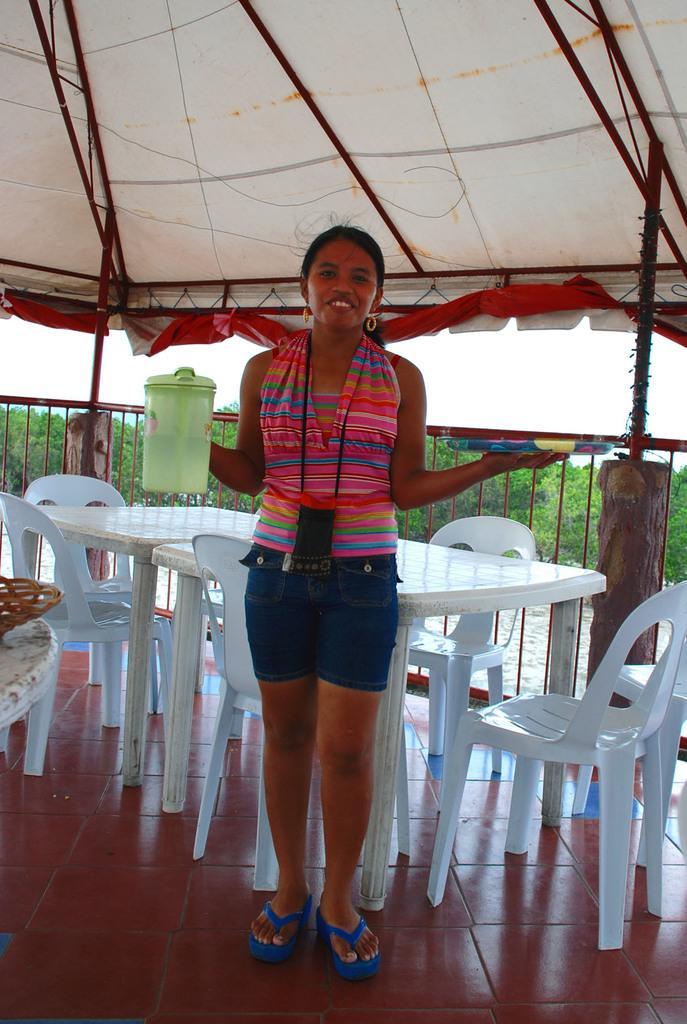How would you summarize this image in a sentence or two? Under the tent there is a girl standing. She is holding a jug in her right hand and a plate in the right hand. And she is carrying a pouch. She is wearing shorts. She is wearing thick blue sleepers. She is smiling. She is wearing a top. There are chairs and dining tables. This is the floor. This is the fence. There are trees outside. There is a basket on the table. The sky is clear. 